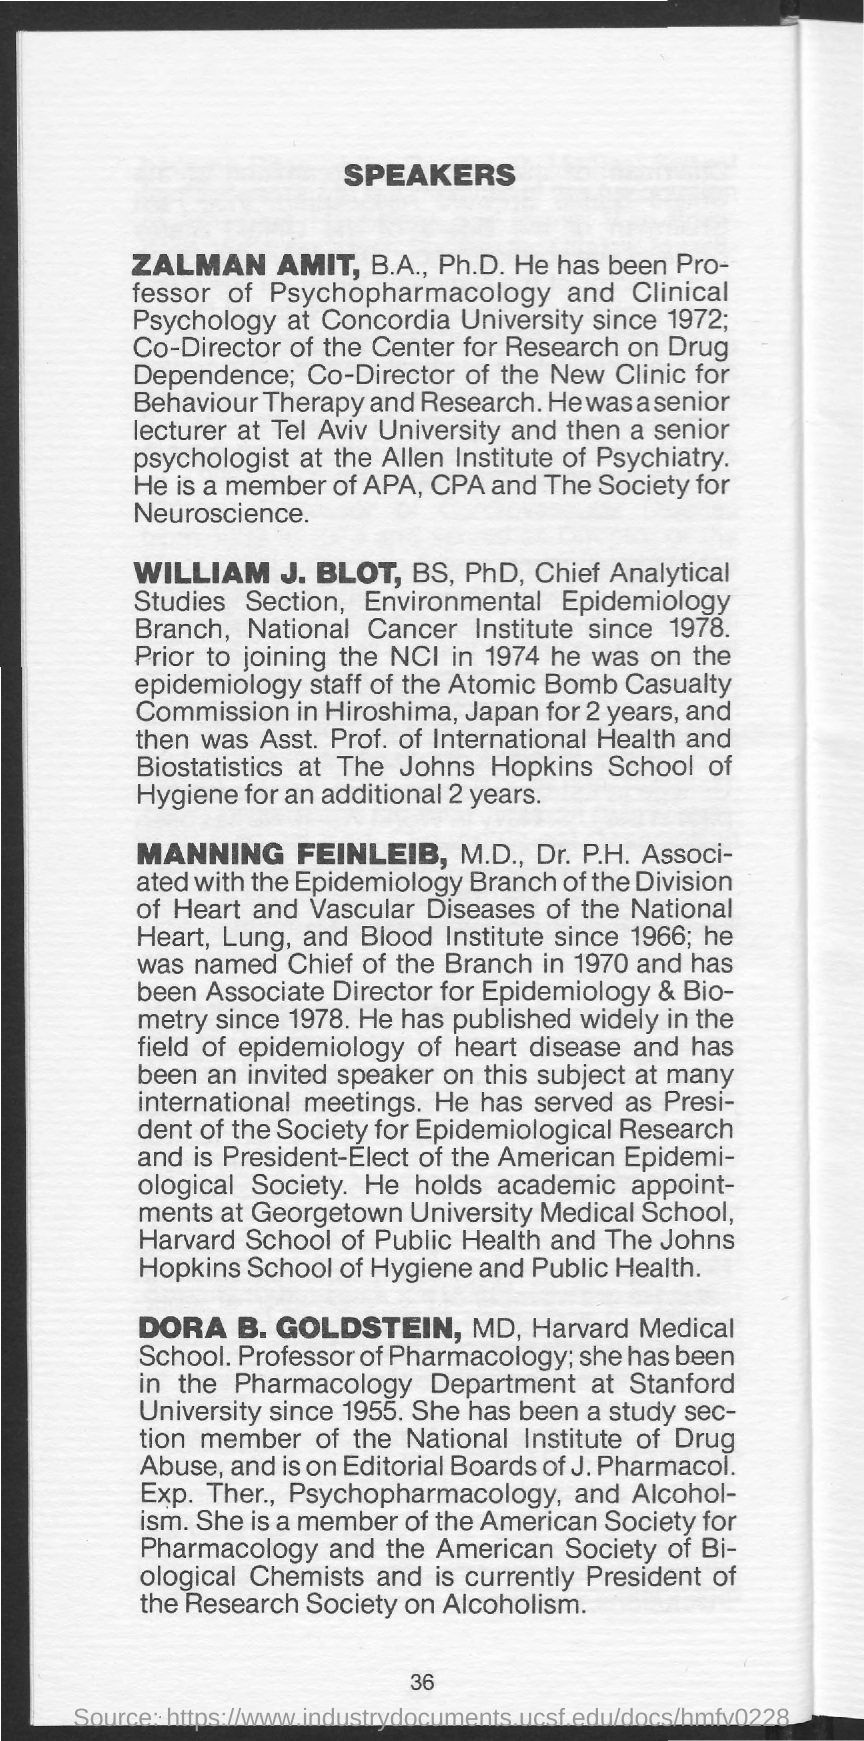What is the Page Number?
Your response must be concise. 36. 